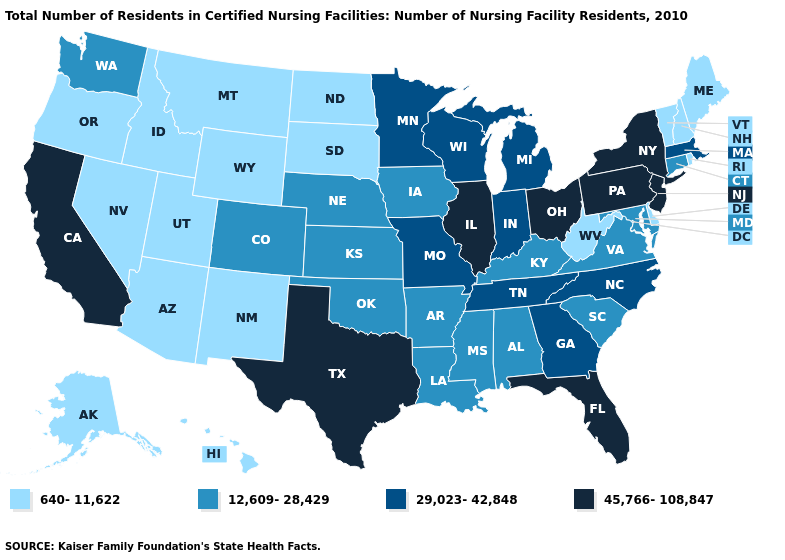What is the value of Montana?
Concise answer only. 640-11,622. Which states have the lowest value in the USA?
Keep it brief. Alaska, Arizona, Delaware, Hawaii, Idaho, Maine, Montana, Nevada, New Hampshire, New Mexico, North Dakota, Oregon, Rhode Island, South Dakota, Utah, Vermont, West Virginia, Wyoming. Name the states that have a value in the range 640-11,622?
Quick response, please. Alaska, Arizona, Delaware, Hawaii, Idaho, Maine, Montana, Nevada, New Hampshire, New Mexico, North Dakota, Oregon, Rhode Island, South Dakota, Utah, Vermont, West Virginia, Wyoming. Which states have the lowest value in the USA?
Write a very short answer. Alaska, Arizona, Delaware, Hawaii, Idaho, Maine, Montana, Nevada, New Hampshire, New Mexico, North Dakota, Oregon, Rhode Island, South Dakota, Utah, Vermont, West Virginia, Wyoming. Does Michigan have the lowest value in the USA?
Give a very brief answer. No. Name the states that have a value in the range 12,609-28,429?
Be succinct. Alabama, Arkansas, Colorado, Connecticut, Iowa, Kansas, Kentucky, Louisiana, Maryland, Mississippi, Nebraska, Oklahoma, South Carolina, Virginia, Washington. Which states hav the highest value in the West?
Write a very short answer. California. Does Indiana have the same value as Missouri?
Concise answer only. Yes. What is the value of North Carolina?
Keep it brief. 29,023-42,848. What is the value of Florida?
Keep it brief. 45,766-108,847. What is the value of Arizona?
Write a very short answer. 640-11,622. Does Alabama have the same value as Nebraska?
Quick response, please. Yes. Name the states that have a value in the range 640-11,622?
Be succinct. Alaska, Arizona, Delaware, Hawaii, Idaho, Maine, Montana, Nevada, New Hampshire, New Mexico, North Dakota, Oregon, Rhode Island, South Dakota, Utah, Vermont, West Virginia, Wyoming. Name the states that have a value in the range 29,023-42,848?
Be succinct. Georgia, Indiana, Massachusetts, Michigan, Minnesota, Missouri, North Carolina, Tennessee, Wisconsin. Among the states that border West Virginia , does Pennsylvania have the lowest value?
Short answer required. No. 